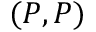<formula> <loc_0><loc_0><loc_500><loc_500>( P , P )</formula> 